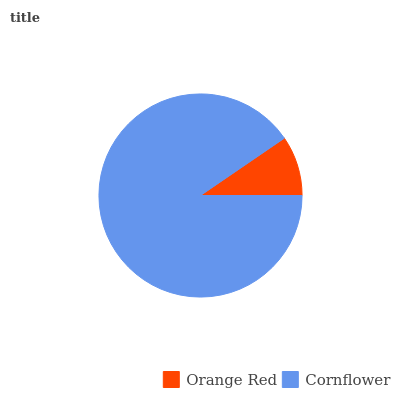Is Orange Red the minimum?
Answer yes or no. Yes. Is Cornflower the maximum?
Answer yes or no. Yes. Is Cornflower the minimum?
Answer yes or no. No. Is Cornflower greater than Orange Red?
Answer yes or no. Yes. Is Orange Red less than Cornflower?
Answer yes or no. Yes. Is Orange Red greater than Cornflower?
Answer yes or no. No. Is Cornflower less than Orange Red?
Answer yes or no. No. Is Cornflower the high median?
Answer yes or no. Yes. Is Orange Red the low median?
Answer yes or no. Yes. Is Orange Red the high median?
Answer yes or no. No. Is Cornflower the low median?
Answer yes or no. No. 